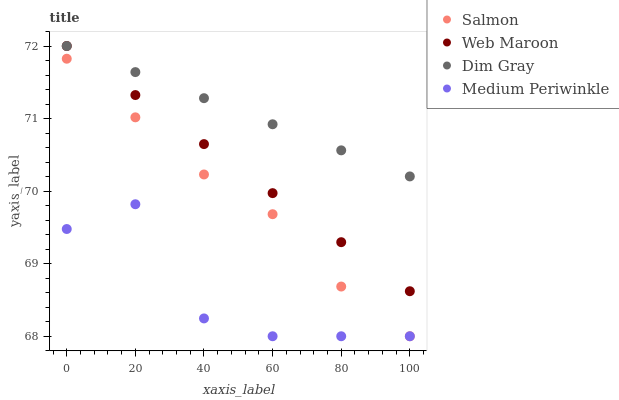Does Medium Periwinkle have the minimum area under the curve?
Answer yes or no. Yes. Does Dim Gray have the maximum area under the curve?
Answer yes or no. Yes. Does Salmon have the minimum area under the curve?
Answer yes or no. No. Does Salmon have the maximum area under the curve?
Answer yes or no. No. Is Dim Gray the smoothest?
Answer yes or no. Yes. Is Medium Periwinkle the roughest?
Answer yes or no. Yes. Is Salmon the smoothest?
Answer yes or no. No. Is Salmon the roughest?
Answer yes or no. No. Does Salmon have the lowest value?
Answer yes or no. Yes. Does Dim Gray have the lowest value?
Answer yes or no. No. Does Dim Gray have the highest value?
Answer yes or no. Yes. Does Salmon have the highest value?
Answer yes or no. No. Is Salmon less than Dim Gray?
Answer yes or no. Yes. Is Web Maroon greater than Medium Periwinkle?
Answer yes or no. Yes. Does Web Maroon intersect Dim Gray?
Answer yes or no. Yes. Is Web Maroon less than Dim Gray?
Answer yes or no. No. Is Web Maroon greater than Dim Gray?
Answer yes or no. No. Does Salmon intersect Dim Gray?
Answer yes or no. No. 